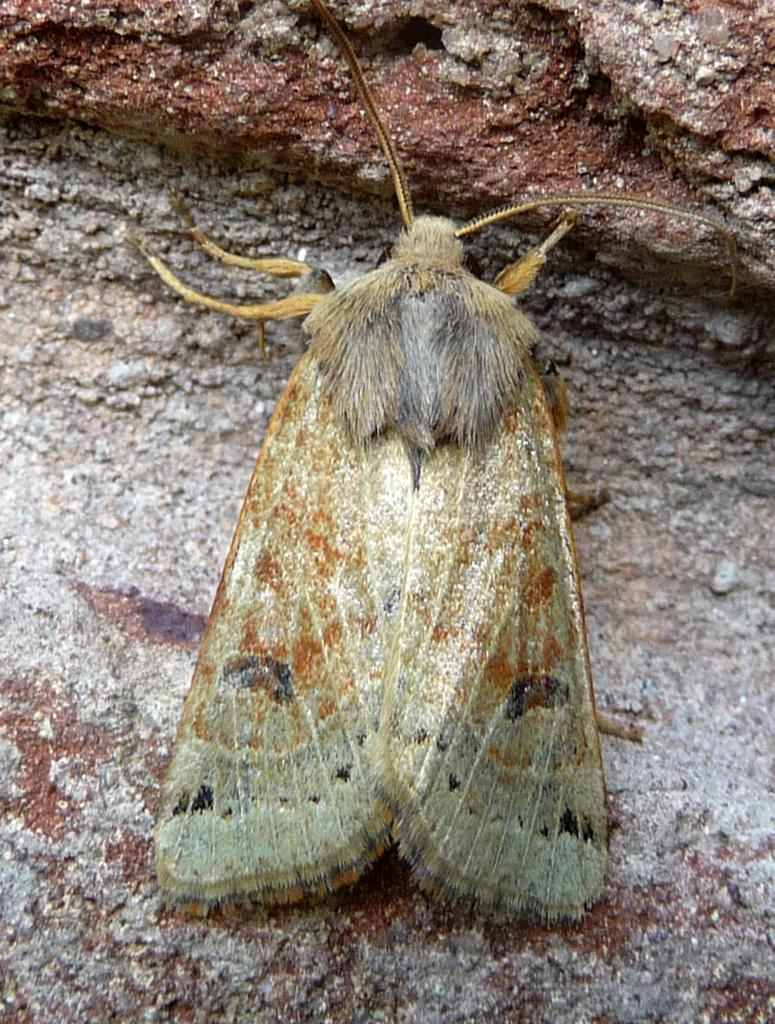What is the main subject in the center of the image? There is an insect in the center of the image. What can be seen in the background of the image? There is a rock in the background of the image. What type of lunch is being served at the meeting in the image? There is no meeting or lunch present in the image; it only features an insect and a rock. 